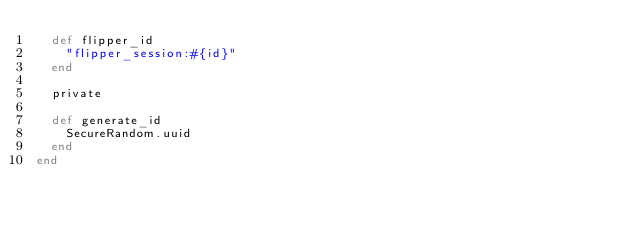Convert code to text. <code><loc_0><loc_0><loc_500><loc_500><_Ruby_>  def flipper_id
    "flipper_session:#{id}"
  end

  private

  def generate_id
    SecureRandom.uuid
  end
end
</code> 